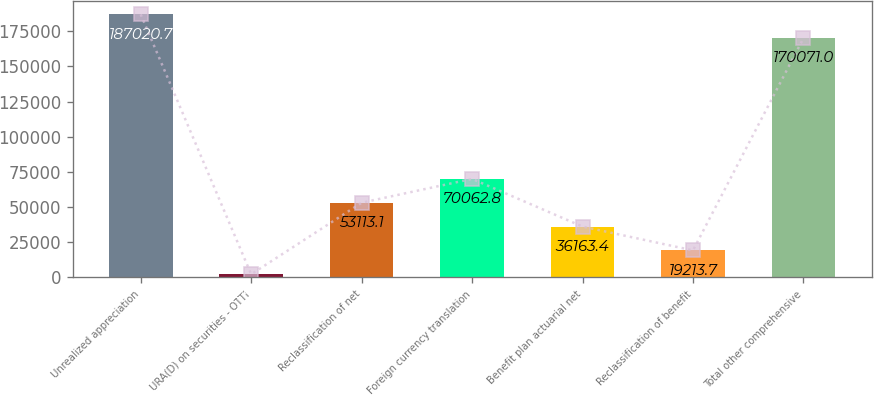Convert chart. <chart><loc_0><loc_0><loc_500><loc_500><bar_chart><fcel>Unrealized appreciation<fcel>URA(D) on securities - OTTI<fcel>Reclassification of net<fcel>Foreign currency translation<fcel>Benefit plan actuarial net<fcel>Reclassification of benefit<fcel>Total other comprehensive<nl><fcel>187021<fcel>2264<fcel>53113.1<fcel>70062.8<fcel>36163.4<fcel>19213.7<fcel>170071<nl></chart> 